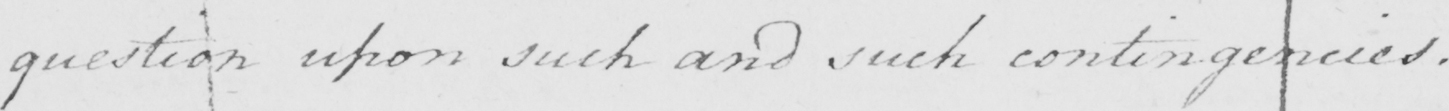Please provide the text content of this handwritten line. question upon such and such contingencies . 